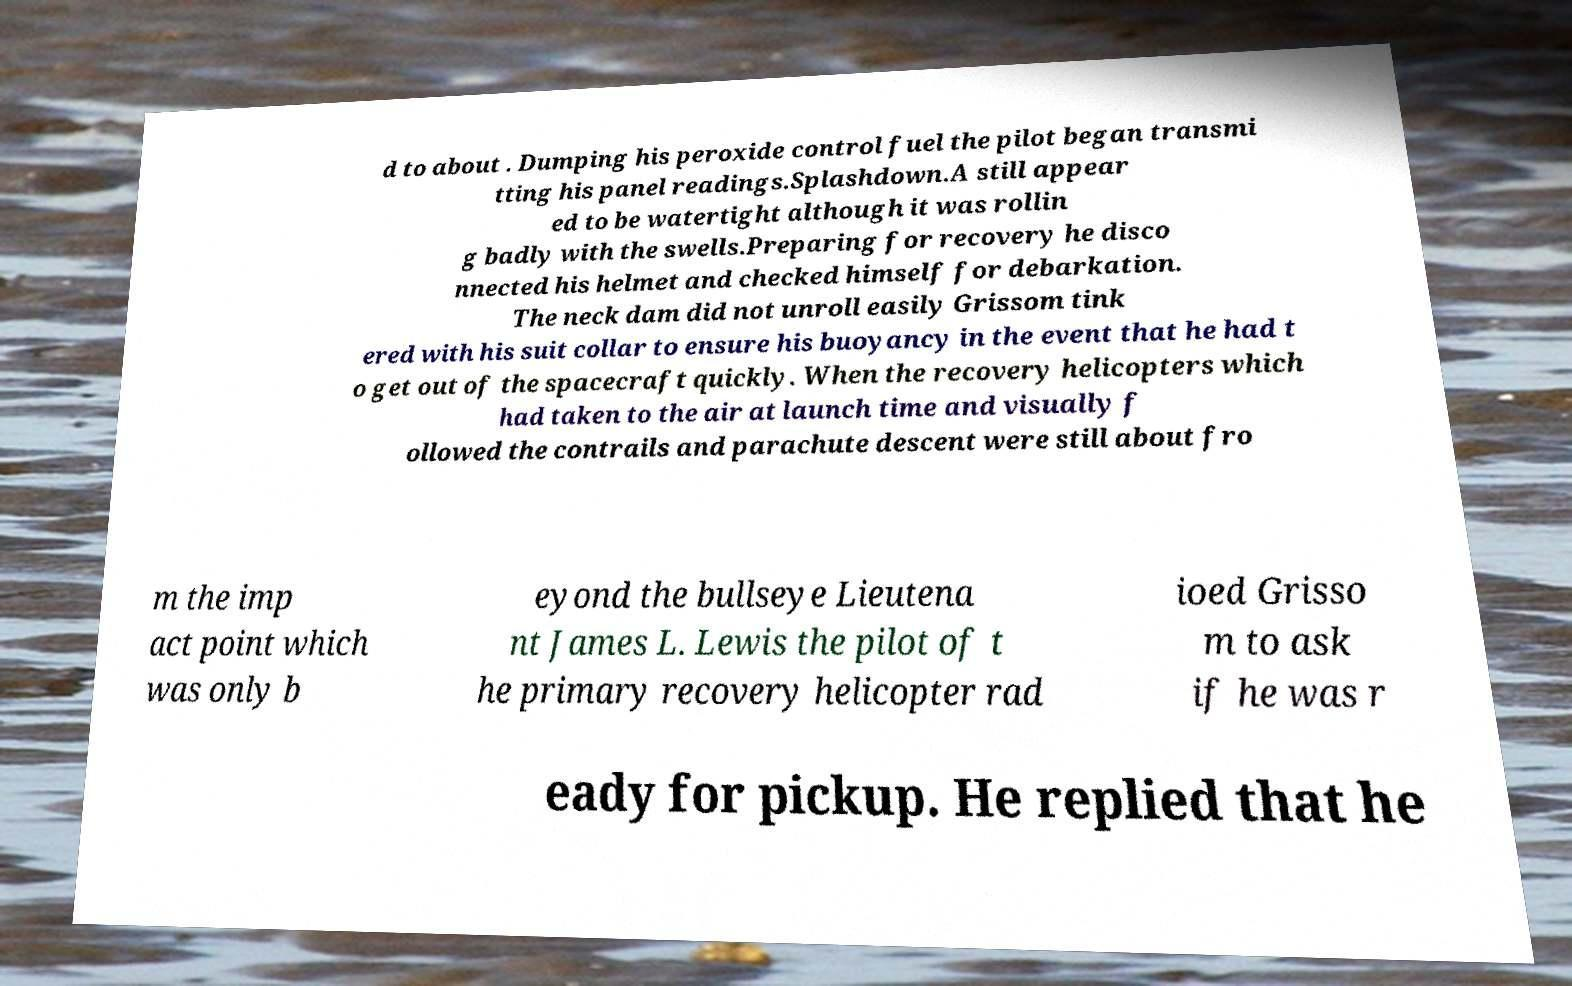There's text embedded in this image that I need extracted. Can you transcribe it verbatim? d to about . Dumping his peroxide control fuel the pilot began transmi tting his panel readings.Splashdown.A still appear ed to be watertight although it was rollin g badly with the swells.Preparing for recovery he disco nnected his helmet and checked himself for debarkation. The neck dam did not unroll easily Grissom tink ered with his suit collar to ensure his buoyancy in the event that he had t o get out of the spacecraft quickly. When the recovery helicopters which had taken to the air at launch time and visually f ollowed the contrails and parachute descent were still about fro m the imp act point which was only b eyond the bullseye Lieutena nt James L. Lewis the pilot of t he primary recovery helicopter rad ioed Grisso m to ask if he was r eady for pickup. He replied that he 